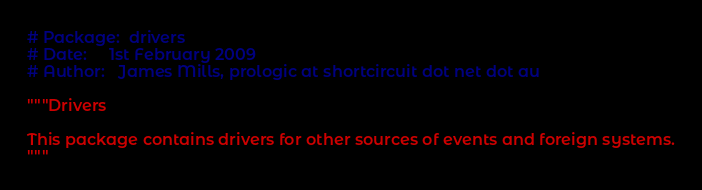<code> <loc_0><loc_0><loc_500><loc_500><_Python_># Package:  drivers
# Date:     1st February 2009
# Author:   James Mills, prologic at shortcircuit dot net dot au

"""Drivers

This package contains drivers for other sources of events and foreign systems.
"""
</code> 